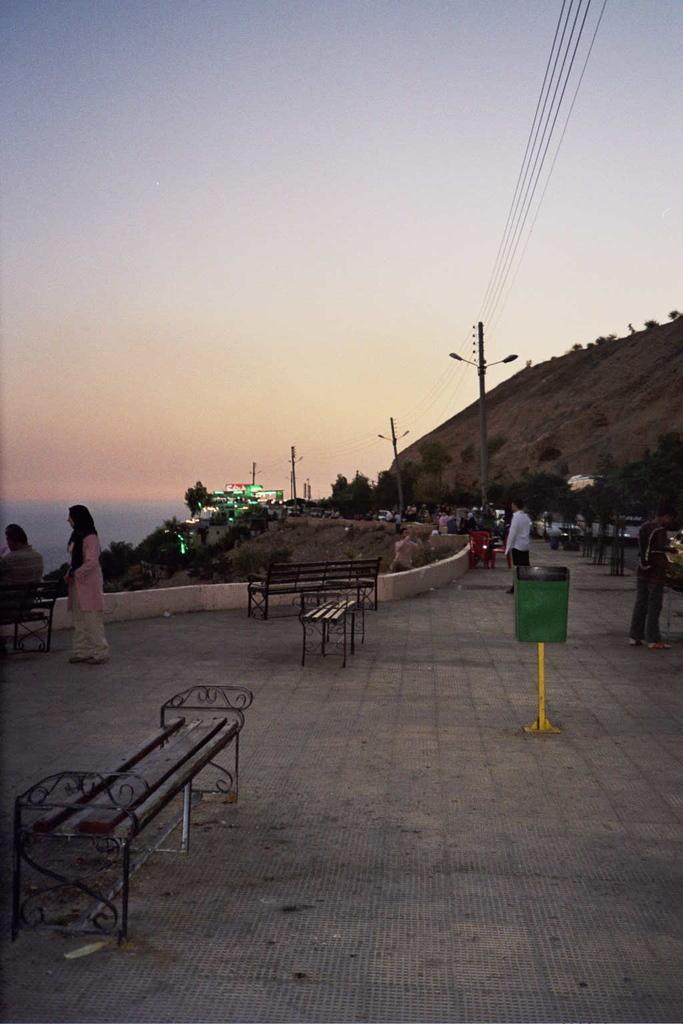What are the people in the image doing? There are persons standing in the image, and one person is sitting on a bench. What is the person sitting on in the image? The person is sitting on a bench. What is attached to the pole in the image? There is a pole with a light in the image. What can be seen in the distance in the image? Trees are visible in the distance. What is the source of light in the image? There is light visible in the image, likely coming from the pole with a light. What is visible above the people and objects in the image? The sky is visible in the image. What type of lace is draped over the bench in the image? There is no lace present in the image; it features a person sitting on a bench and other objects. What idea is being discussed by the people in the image? There is no indication of a discussion or idea being shared in the image; it simply shows people standing and sitting in a particular setting. 